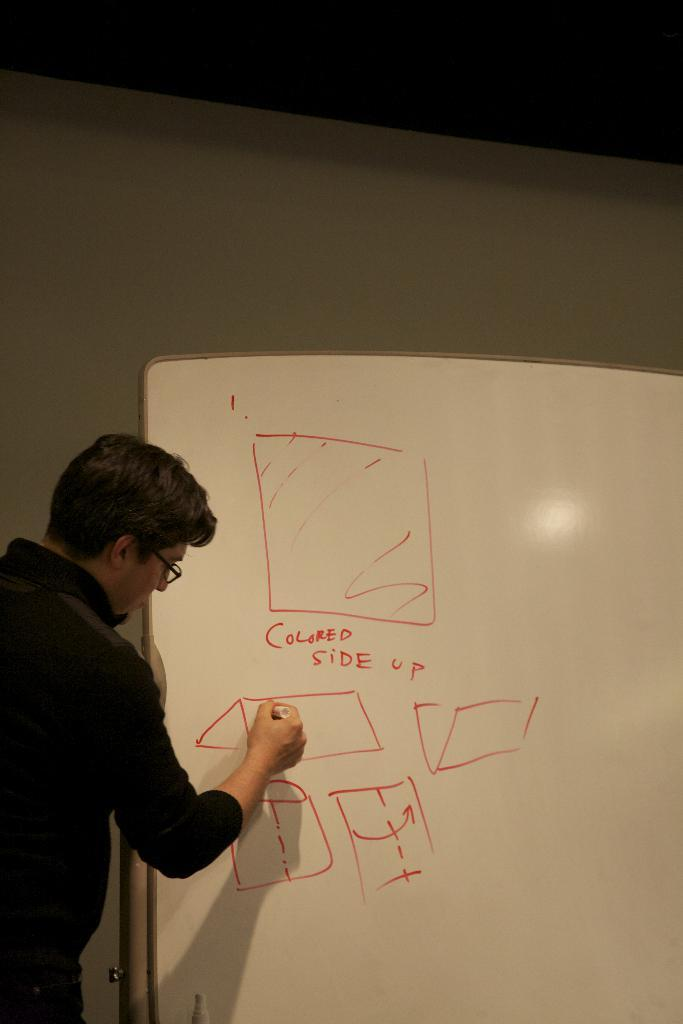<image>
Summarize the visual content of the image. a man drawing different shapes and text that reads colored side up on a white marker board 